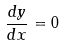<formula> <loc_0><loc_0><loc_500><loc_500>\frac { d y } { d x } = 0</formula> 